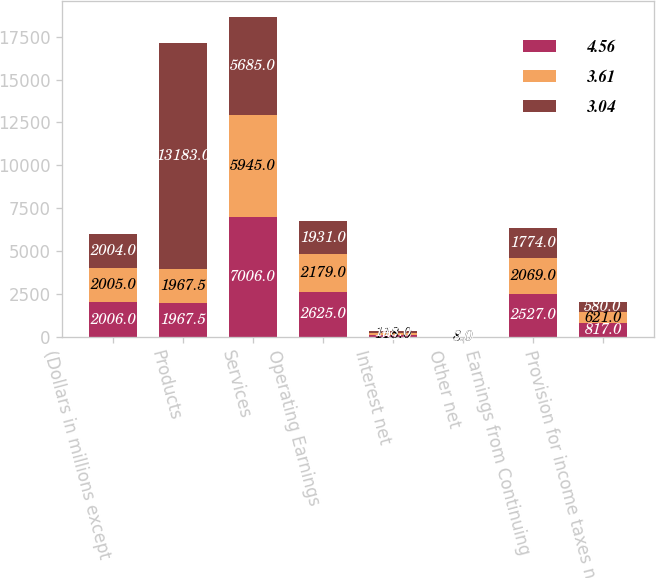Convert chart. <chart><loc_0><loc_0><loc_500><loc_500><stacked_bar_chart><ecel><fcel>(Dollars in millions except<fcel>Products<fcel>Services<fcel>Operating Earnings<fcel>Interest net<fcel>Other net<fcel>Earnings from Continuing<fcel>Provision for income taxes net<nl><fcel>4.56<fcel>2006<fcel>1967.5<fcel>7006<fcel>2625<fcel>101<fcel>3<fcel>2527<fcel>817<nl><fcel>3.61<fcel>2005<fcel>1967.5<fcel>5945<fcel>2179<fcel>118<fcel>8<fcel>2069<fcel>621<nl><fcel>3.04<fcel>2004<fcel>13183<fcel>5685<fcel>1931<fcel>148<fcel>9<fcel>1774<fcel>580<nl></chart> 